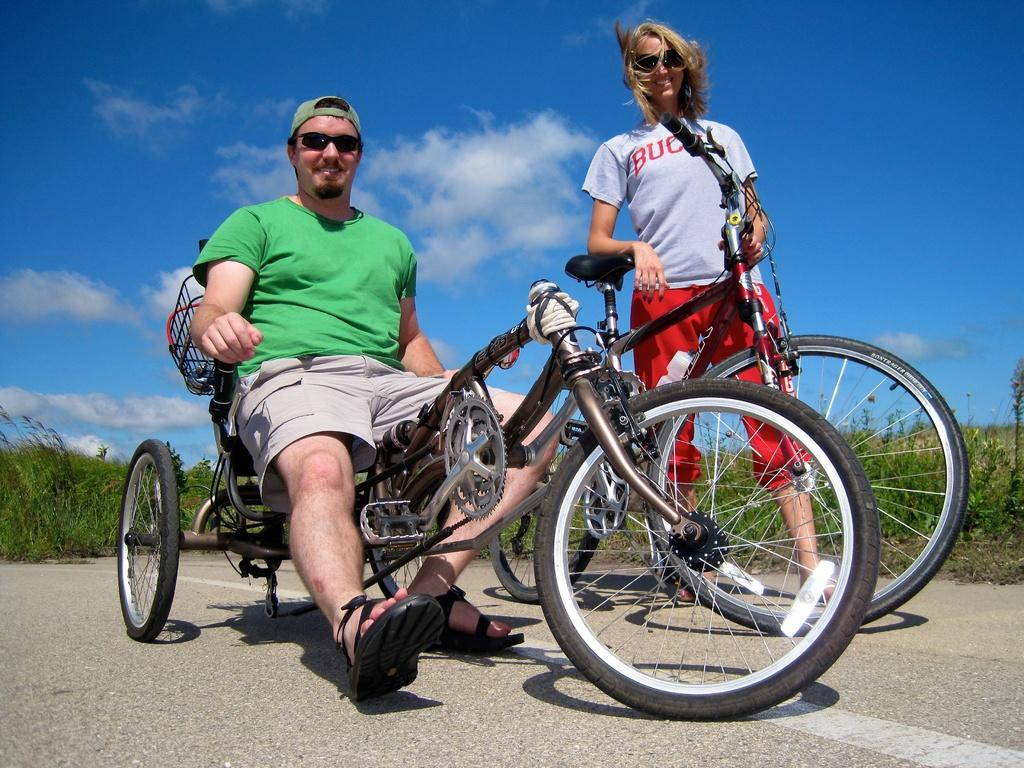Who are the people in the image? There is a man and a woman in the image. What is the man doing in the image? The man is seated on a bicycle. What is the relationship between the man and the woman in the image? The facts provided do not specify the relationship between the man and the woman. What can be seen in the background of the image? There are plants and clouds visible in the background of the image. How many bicycles are present in the image? There are two bicycles in the image, one with the man seated on it and another beside him. What type of cloth is the man using to drop from the bicycle in the image? There is no cloth present in the image, nor is the man dropping from the bicycle. 